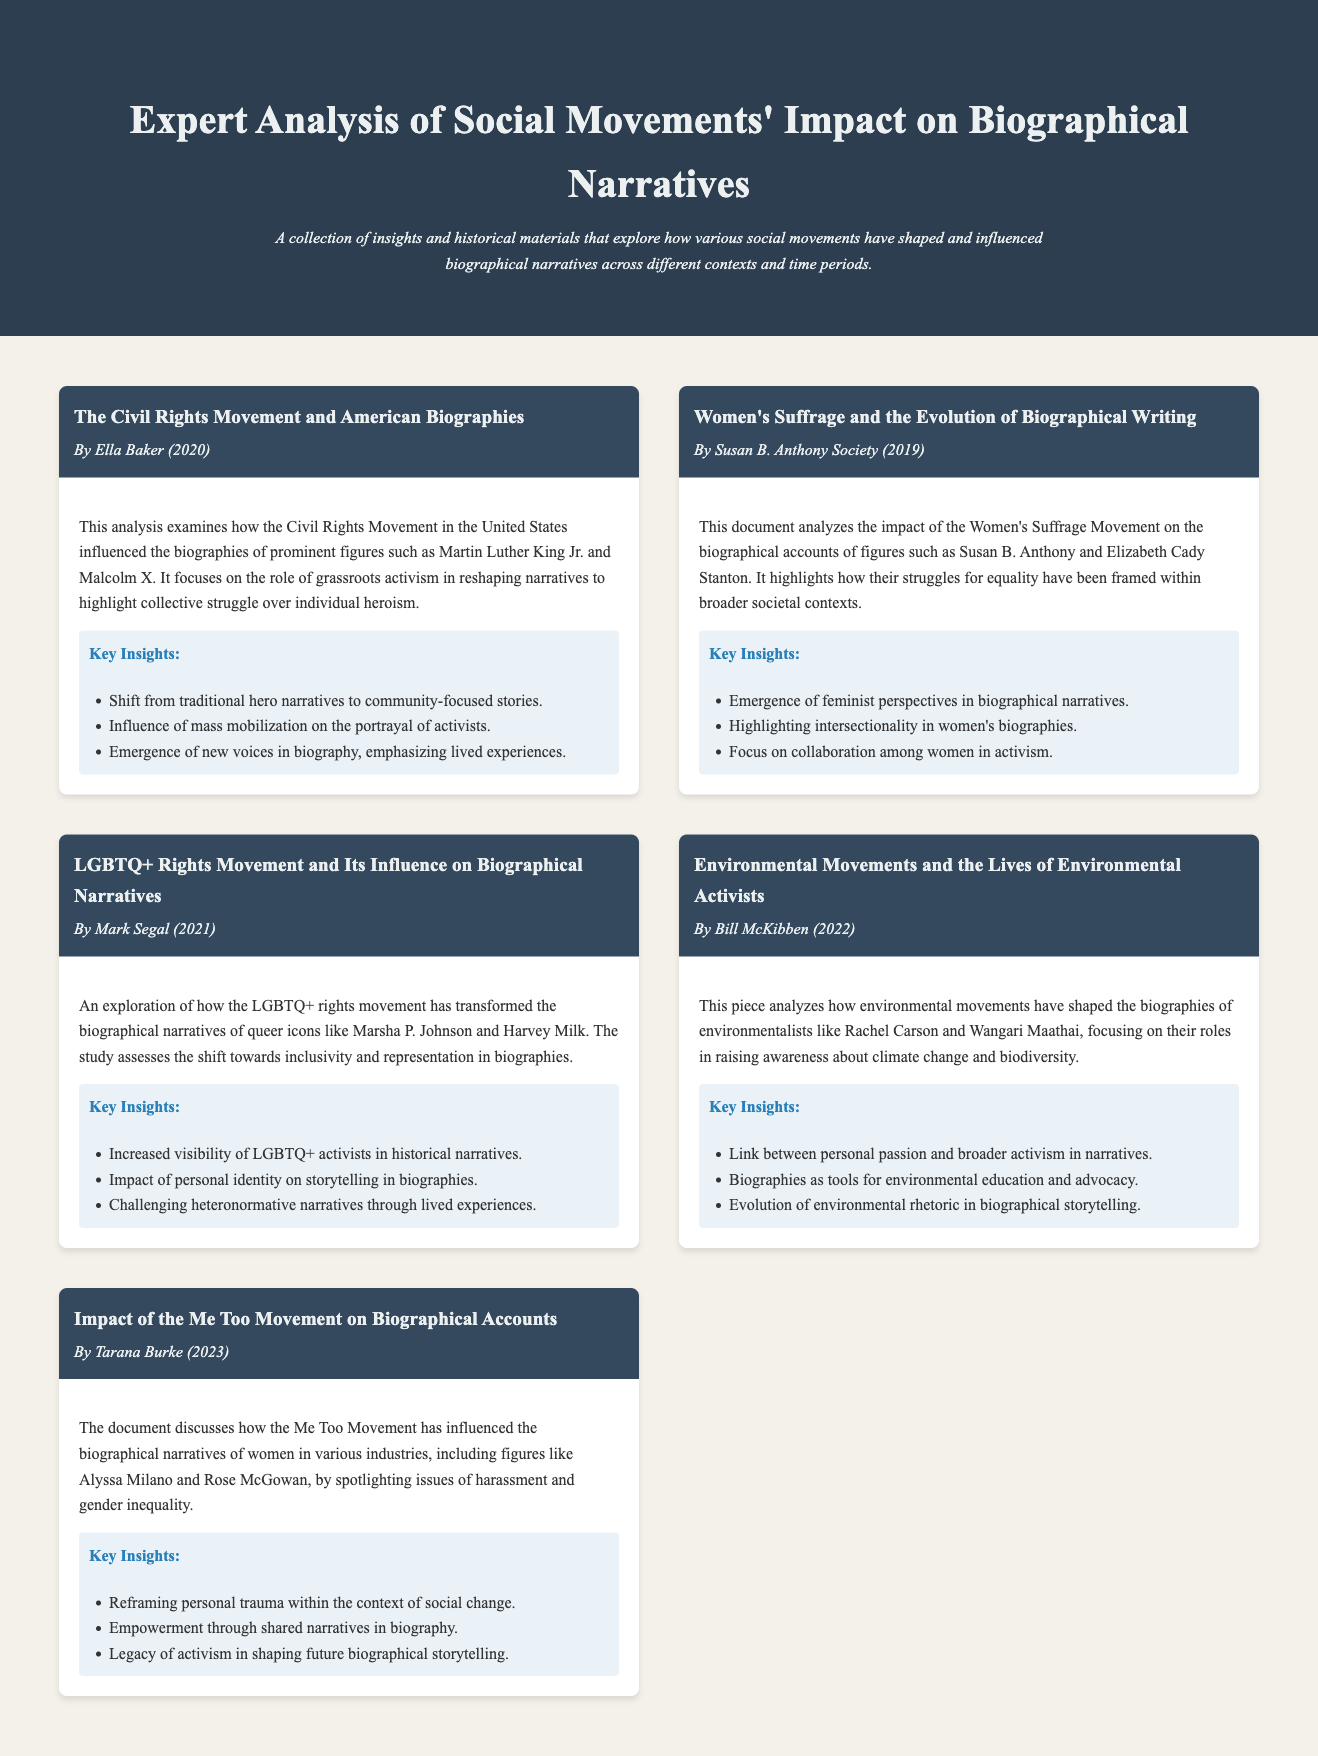What is the title of the first material? The title of the first material is specified in the document header of that section.
Answer: The Civil Rights Movement and American Biographies Who is the author of the analysis on Women's Suffrage? The author's name is mentioned directly under the material's title.
Answer: Susan B. Anthony Society In what year was the LGBTQ+ rights movement analysis published? The year of publication is included in the material header.
Answer: 2021 What is one key insight from the analysis on environmental movements? Insights are outlined in a specific section of the document for each material.
Answer: Link between personal passion and broader activism in narratives How many materials are listed in the document? The total number of materials is the count of each individual material section present in the document.
Answer: Five 